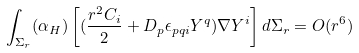Convert formula to latex. <formula><loc_0><loc_0><loc_500><loc_500>\int _ { \Sigma _ { r } } ( \alpha _ { H } ) \left [ ( \frac { r ^ { 2 } C _ { i } } { 2 } + D _ { p } \epsilon _ { p q i } Y ^ { q } ) \nabla Y ^ { i } \right ] d \Sigma _ { r } = O ( r ^ { 6 } )</formula> 